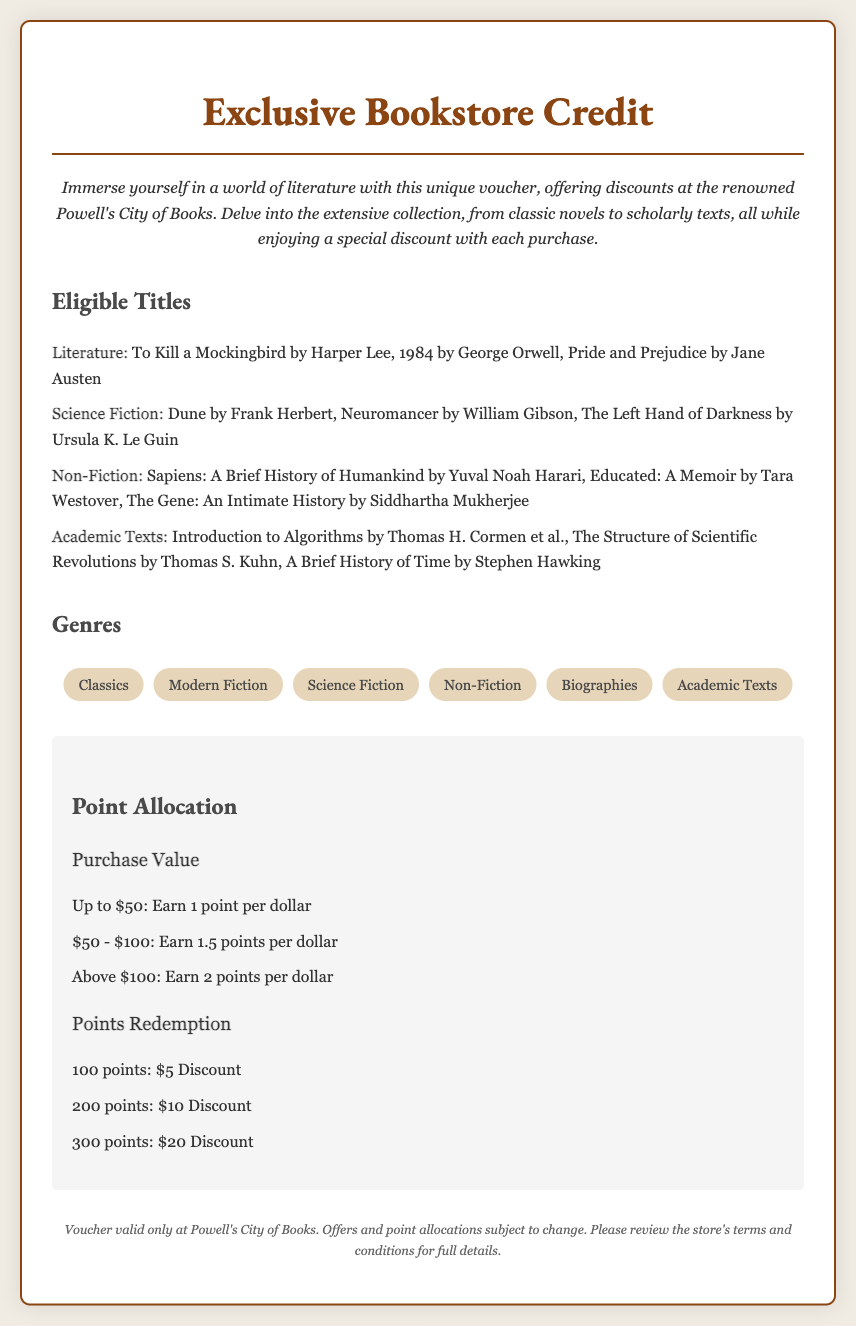What is the name of the bookstore? The document mentions Powell's City of Books as the renowned bookstore.
Answer: Powell's City of Books What genre does "1984" belong to? The title "1984" is listed under the Literature category in the eligible titles.
Answer: Literature How many points do you earn for a purchase between $50 and $100? The document states that purchases in this range earn 1.5 points per dollar.
Answer: 1.5 points What discount can be redeemed for 300 points? According to the point redemption section, 300 points can be redeemed for a $20 discount.
Answer: $20 Discount What is the footnote about? The footnote provides information regarding the voucher's validity and conditions for use at the bookstore.
Answer: Voucher validity and conditions Name one book listed under Non-Fiction. The document lists "Sapiens: A Brief History of Humankind" as an eligible Non-Fiction title.
Answer: Sapiens: A Brief History of Humankind How many points do you earn on a $30 purchase? For a purchase up to $50, you earn 1 point per dollar, hence you earn 30 points on $30.
Answer: 30 points What is the color of the voucher's border? The voucher's border is described as being a shade reminiscent of brown, specifically #8b4513.
Answer: Brown What style is used for the heading "Exclusive Bookstore Credit"? The heading is styled using the font 'EB Garamond' and is centered.
Answer: EB Garamond 